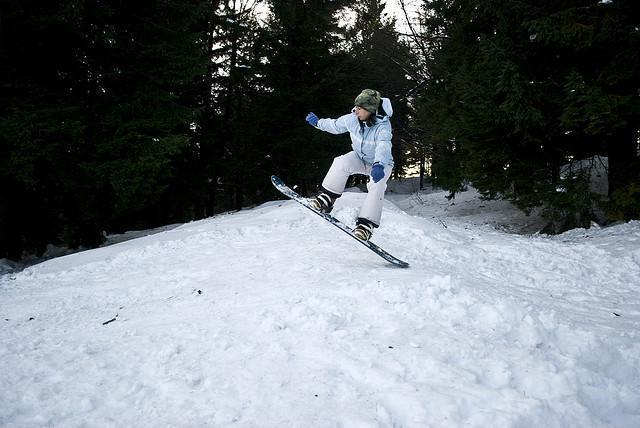How many people can be seen?
Give a very brief answer. 1. How many of the stuffed bears have a heart on its chest?
Give a very brief answer. 0. 